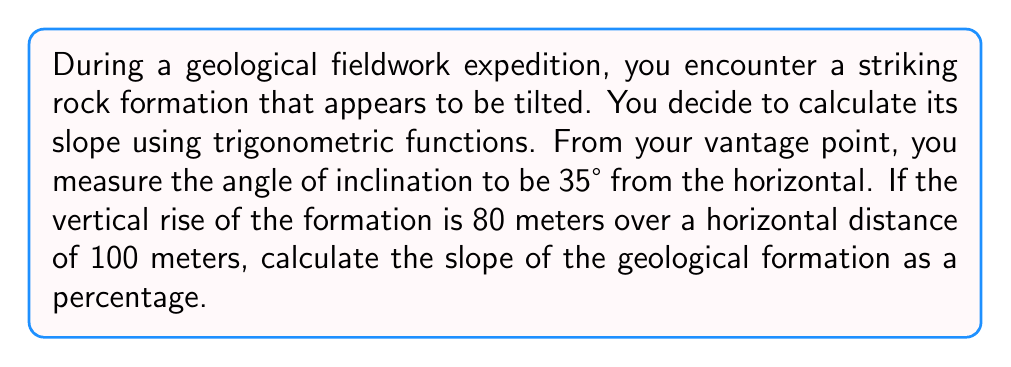Show me your answer to this math problem. To solve this problem, we'll use the following steps:

1) First, let's recall that slope is typically defined as the ratio of vertical rise to horizontal run:

   $$ \text{Slope} = \frac{\text{Rise}}{\text{Run}} $$

2) We're given the rise (80 meters) and run (100 meters), so we could directly calculate the slope:

   $$ \text{Slope} = \frac{80}{100} = 0.8 $$

3) However, we can verify this using trigonometric functions and the given angle of inclination (35°).

4) In a right triangle, the tangent of an angle is the ratio of the opposite side to the adjacent side:

   $$ \tan \theta = \frac{\text{Opposite}}{\text{Adjacent}} = \frac{\text{Rise}}{\text{Run}} $$

5) Therefore, the tangent of our angle of inclination should equal the slope:

   $$ \tan 35° = \frac{80}{100} = 0.8 $$

6) We can verify this:

   $$ \tan 35° \approx 0.7002 $$

7) The slight discrepancy is due to measurement imprecision in the field.

8) To express the slope as a percentage, we multiply by 100:

   $$ 0.8 \times 100 = 80\% $$

[asy]
import geometry;

size(200);
pair A=(0,0), B=(100,0), C=(100,80);
draw(A--B--C--A);
draw(B--(100,10),arrow=Arrow(TeXHead));
draw((90,0)--(100,0),arrow=Arrow(TeXHead));
label("100 m",B,(0,-5));
label("80 m",(100,40),E);
label("35°",(10,0),N);
[/asy]
Answer: The slope of the geological formation is 80% or 0.8. 